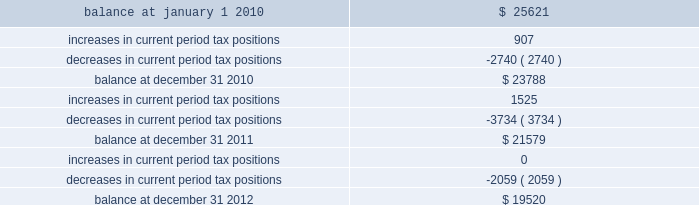The table summarizes the changes in the company 2019s valuation allowance: .
Note 14 : employee benefits pension and other postretirement benefits the company maintains noncontributory defined benefit pension plans covering eligible employees of its regulated utility and shared services operations .
Benefits under the plans are based on the employee 2019s years of service and compensation .
The pension plans have been closed for most employees hired on or after january 1 , 2006 .
Union employees hired on or after january 1 , 2001 had their accrued benefit frozen and will be able to receive this benefit as a lump sum upon termination or retirement .
Union employees hired on or after january 1 , 2001 and non-union employees hired on or after january 1 , 2006 are provided with a 5.25% ( 5.25 % ) of base pay defined contribution plan .
The company does not participate in a multiemployer plan .
The company 2019s funding policy is to contribute at least the greater of the minimum amount required by the employee retirement income security act of 1974 or the normal cost , and an additional contribution if needed to avoid 201cat risk 201d status and benefit restrictions under the pension protection act of 2006 .
The company may also increase its contributions , if appropriate , to its tax and cash position and the plan 2019s funded position .
Pension plan assets are invested in a number of actively managed and indexed investments including equity and bond mutual funds , fixed income securities and guaranteed interest contracts with insurance companies .
Pension expense in excess of the amount contributed to the pension plans is deferred by certain regulated subsidiaries pending future recovery in rates charged for utility services as contributions are made to the plans .
( see note 6 ) the company also has several unfunded noncontributory supplemental non-qualified pension plans that provide additional retirement benefits to certain employees .
The company maintains other postretirement benefit plans providing varying levels of medical and life insurance to eligible retirees .
The retiree welfare plans are closed for union employees hired on or after january 1 , 2006 .
The plans had previously closed for non-union employees hired on or after january 1 , 2002 .
The company 2019s policy is to fund other postretirement benefit costs for rate-making purposes .
Plan assets are invested in equity and bond mutual funds , fixed income securities , real estate investment trusts ( 201creits 201d ) and emerging market funds .
The obligations of the plans are dominated by obligations for active employees .
Because the timing of expected benefit payments is so far in the future and the size of the plan assets are small relative to the company 2019s assets , the investment strategy is to allocate a significant percentage of assets to equities , which the company believes will provide the highest return over the long-term period .
The fixed income assets are invested in long duration debt securities and may be invested in fixed income instruments , such as futures and options in order to better match the duration of the plan liability. .
How much did the company 2019s valuation allowance decrease from 2011 to 2012? 
Computations: ((19520 - 21579) / 21579)
Answer: -0.09542. 